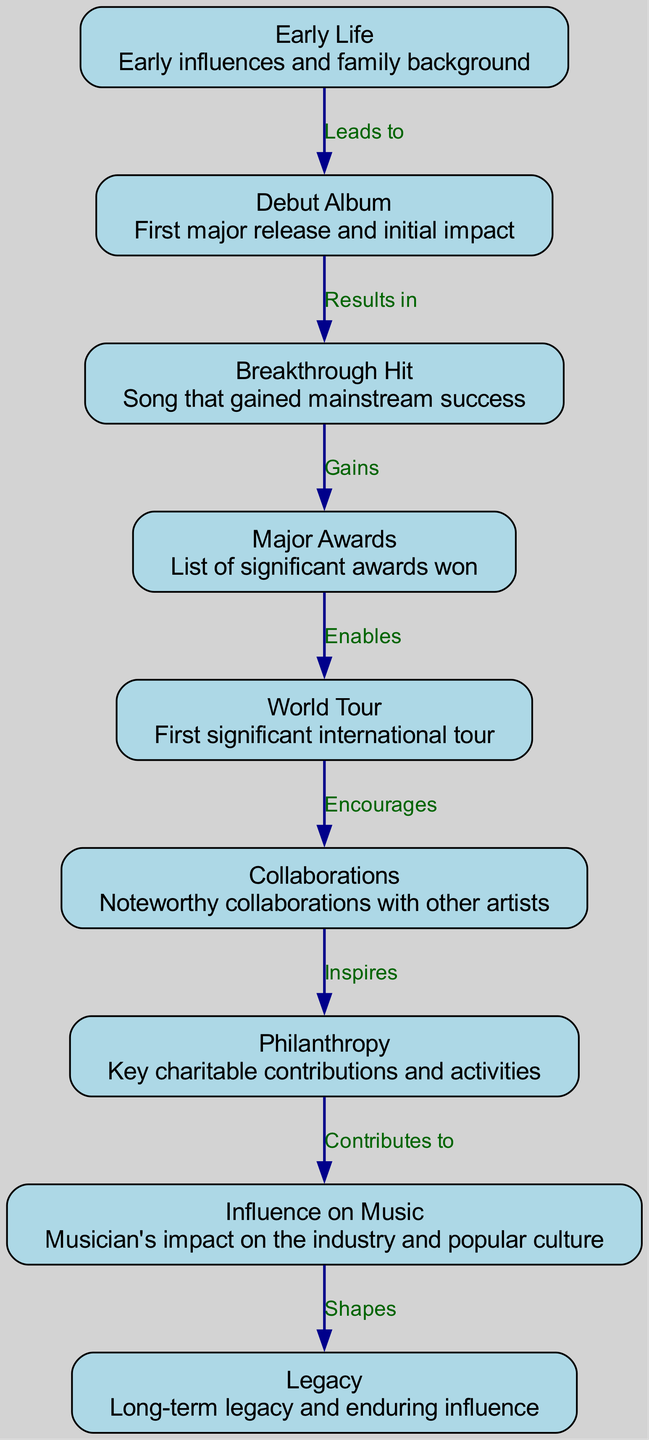What is the first milestone in the evolution of a music icon depicted in the diagram? The diagram starts with the node labeled "Early Life," which represents the foundational influences and background of the musician.
Answer: Early Life How many major milestones are represented in the diagram? The diagram includes a total of nine distinct nodes, each representing a key milestone in the music icon's career.
Answer: 9 What does the "Debut Album" lead to in the diagram? The edge connecting "Debut Album" to "Breakthrough Hit" indicates that the debut album leads to the musician's first major hit song, emphasizing the progression in their career.
Answer: Breakthrough Hit What significant event does "Major Awards" enable? The edge from "Major Awards" to "World Tour" shows that winning major awards enables the opportunity for the musician to embark on their first significant international tour.
Answer: World Tour Which node contributes to the musician's influence on music? The diagram shows that "Philanthropy," which sits in the flow after "Collaborations," contributes to the musician's influence on music and popular culture, illustrating the connections between artistic endeavors and social contributions.
Answer: Philanthropy What relationship exists between "Collaborations" and "Philanthropy"? The diagram features an edge from "Collaborations" to "Philanthropy," indicating that any noteworthy collaborations may inspire the musician's charitable contributions and activities.
Answer: Inspires Which node symbolizes the musician's long-term effect on the industry? At the end of the flow from "Influence on Music," the diagram leads to "Legacy," representing the lasting impact and enduring influence of the musician on the music industry and culture.
Answer: Legacy What milestone follows immediately after "Breakthrough Hit"? The diagram indicates a direct connection from "Breakthrough Hit" to "Major Awards," meaning that following the breakthrough song, the musician achieves recognition through significant awards.
Answer: Major Awards Which milestone comes before "World Tour"? The direct edge in the diagram shows that "Major Awards" precedes the "World Tour," highlighting that recognition likely facilitated international touring opportunities.
Answer: Major Awards 